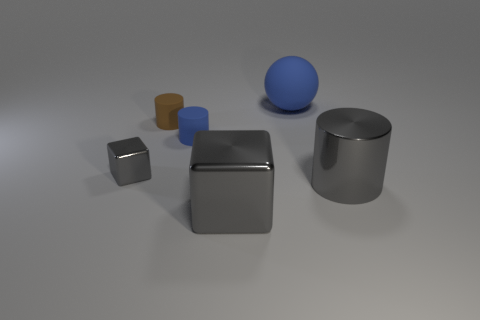Add 1 large blue things. How many objects exist? 7 Subtract all balls. How many objects are left? 5 Subtract 0 brown spheres. How many objects are left? 6 Subtract all gray cubes. Subtract all small blue rubber cylinders. How many objects are left? 3 Add 2 brown things. How many brown things are left? 3 Add 4 small blue rubber objects. How many small blue rubber objects exist? 5 